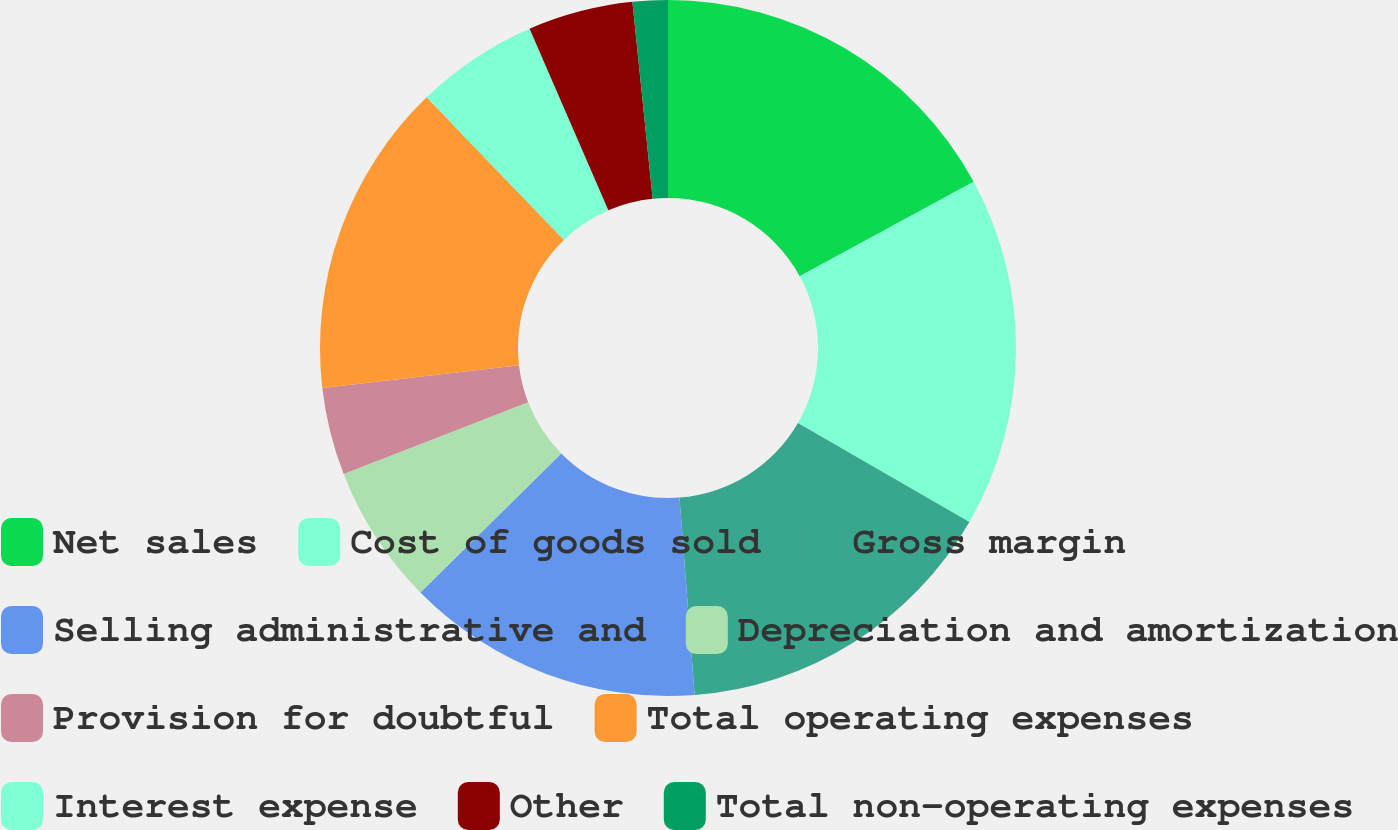<chart> <loc_0><loc_0><loc_500><loc_500><pie_chart><fcel>Net sales<fcel>Cost of goods sold<fcel>Gross margin<fcel>Selling administrative and<fcel>Depreciation and amortization<fcel>Provision for doubtful<fcel>Total operating expenses<fcel>Interest expense<fcel>Other<fcel>Total non-operating expenses<nl><fcel>17.07%<fcel>16.26%<fcel>15.45%<fcel>13.82%<fcel>6.5%<fcel>4.07%<fcel>14.63%<fcel>5.69%<fcel>4.88%<fcel>1.63%<nl></chart> 